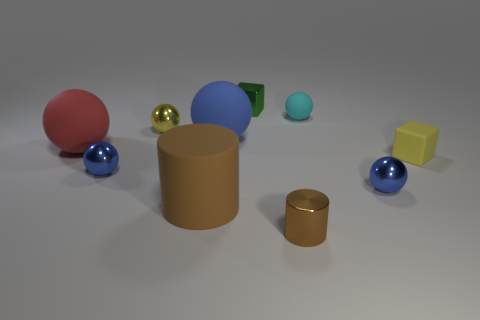Are there any small purple blocks that have the same material as the large blue ball?
Make the answer very short. No. What is the material of the cyan object that is the same size as the yellow ball?
Provide a short and direct response. Rubber. What is the size of the yellow object that is to the left of the blue shiny ball that is to the right of the big rubber object that is in front of the large red matte sphere?
Your answer should be very brief. Small. Is there a small blue sphere that is right of the small object behind the cyan matte object?
Provide a short and direct response. Yes. There is a large brown thing; is it the same shape as the small blue metal object that is left of the small brown cylinder?
Provide a short and direct response. No. What color is the cylinder that is on the right side of the green metal object?
Offer a very short reply. Brown. There is a rubber ball that is on the left side of the small metal sphere that is behind the rubber cube; what size is it?
Give a very brief answer. Large. Is the shape of the yellow object that is right of the small green metal thing the same as  the small cyan object?
Your answer should be very brief. No. What is the material of the other thing that is the same shape as the brown shiny thing?
Your response must be concise. Rubber. What number of things are either rubber objects on the left side of the brown metallic thing or small objects that are on the right side of the tiny cyan rubber thing?
Keep it short and to the point. 5. 